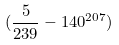Convert formula to latex. <formula><loc_0><loc_0><loc_500><loc_500>( \frac { 5 } { 2 3 9 } - 1 4 0 ^ { 2 0 7 } )</formula> 